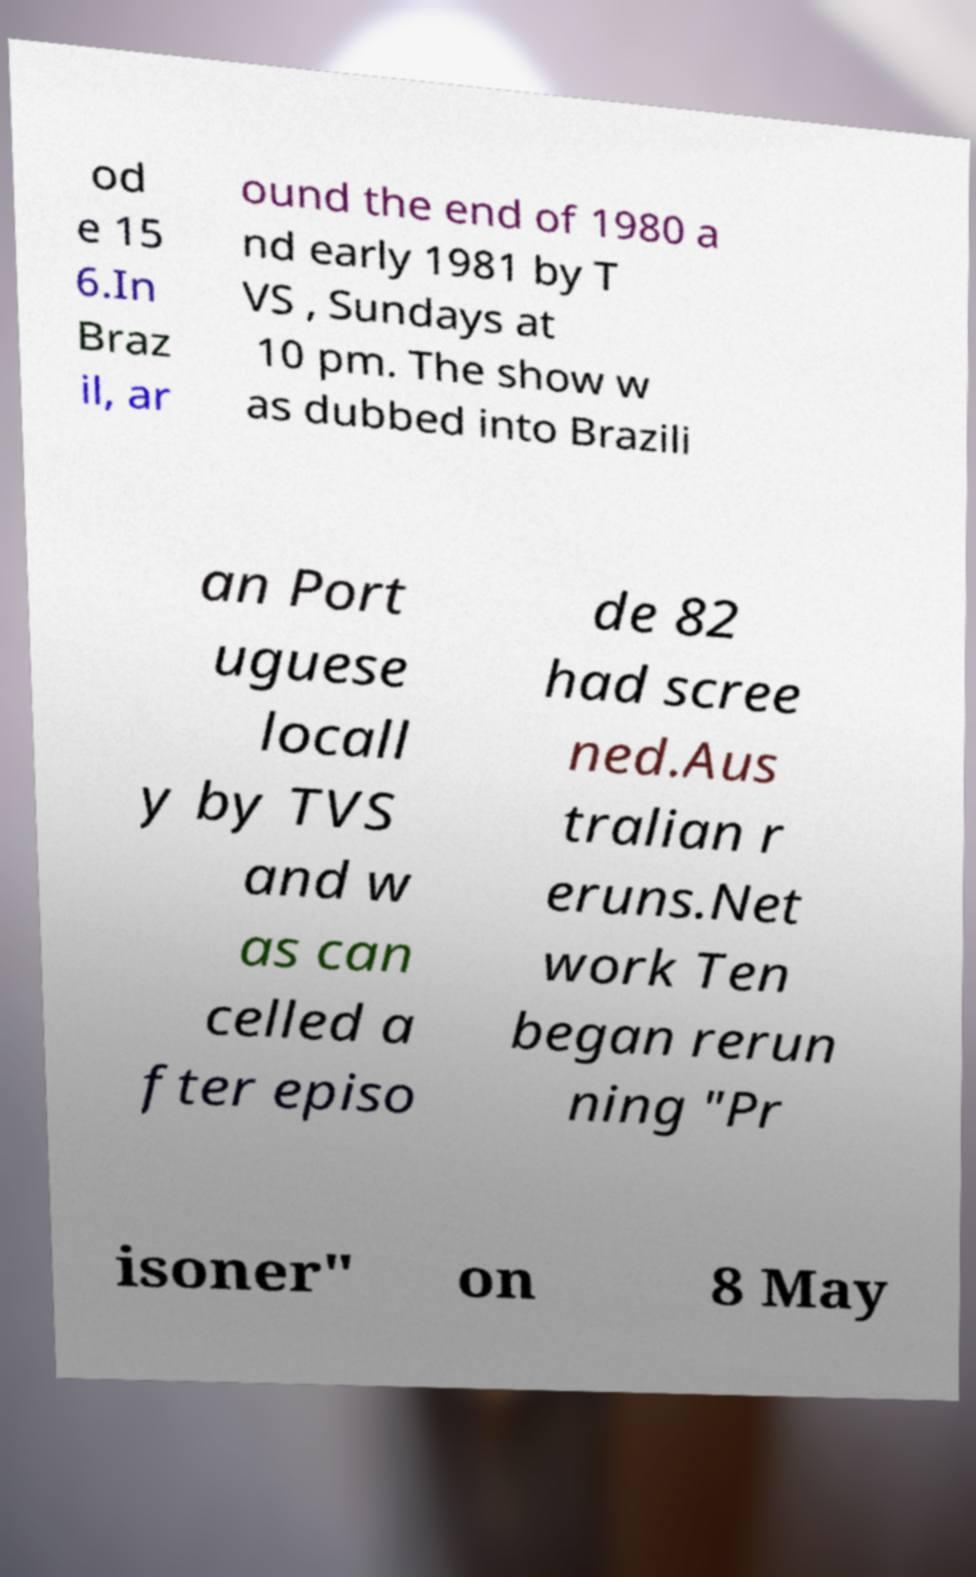Could you assist in decoding the text presented in this image and type it out clearly? od e 15 6.In Braz il, ar ound the end of 1980 a nd early 1981 by T VS , Sundays at 10 pm. The show w as dubbed into Brazili an Port uguese locall y by TVS and w as can celled a fter episo de 82 had scree ned.Aus tralian r eruns.Net work Ten began rerun ning "Pr isoner" on 8 May 